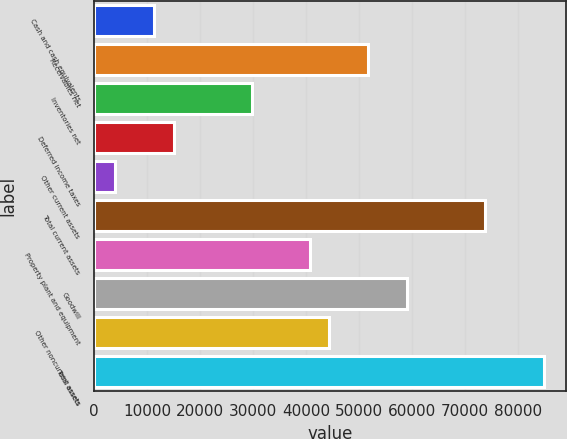Convert chart to OTSL. <chart><loc_0><loc_0><loc_500><loc_500><bar_chart><fcel>Cash and cash equivalents<fcel>Receivables net<fcel>Inventories net<fcel>Deferred income taxes<fcel>Other current assets<fcel>Total current assets<fcel>Property plant and equipment<fcel>Goodwill<fcel>Other noncurrent assets<fcel>Total assets<nl><fcel>11341.7<fcel>51776.6<fcel>29721.2<fcel>15017.6<fcel>3989.9<fcel>73832<fcel>40748.9<fcel>59128.4<fcel>44424.8<fcel>84859.7<nl></chart> 